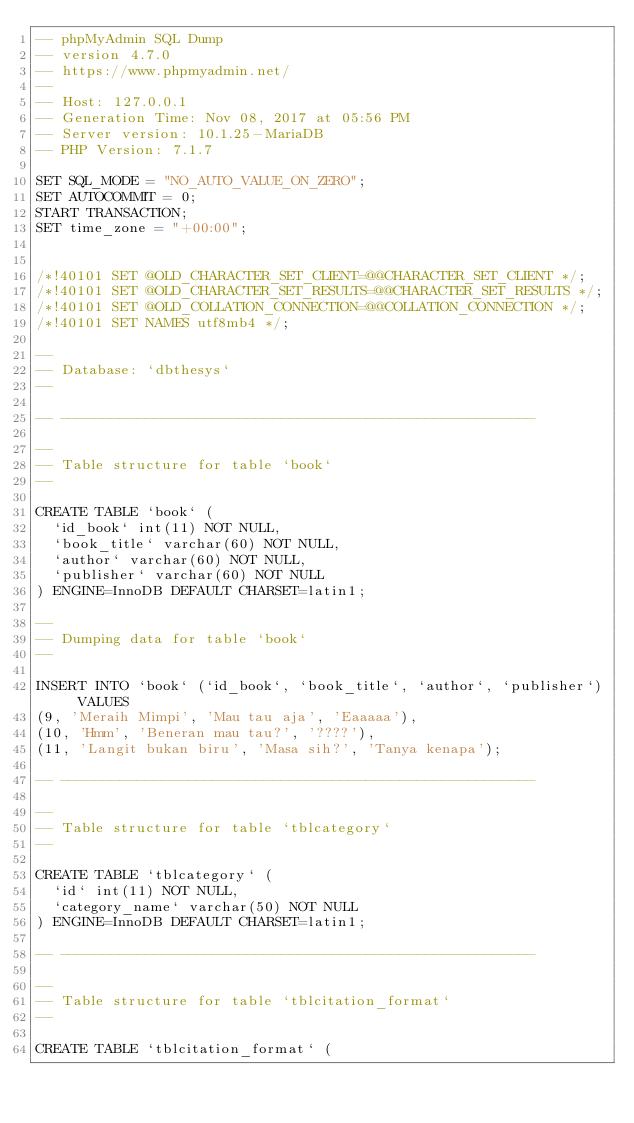<code> <loc_0><loc_0><loc_500><loc_500><_SQL_>-- phpMyAdmin SQL Dump
-- version 4.7.0
-- https://www.phpmyadmin.net/
--
-- Host: 127.0.0.1
-- Generation Time: Nov 08, 2017 at 05:56 PM
-- Server version: 10.1.25-MariaDB
-- PHP Version: 7.1.7

SET SQL_MODE = "NO_AUTO_VALUE_ON_ZERO";
SET AUTOCOMMIT = 0;
START TRANSACTION;
SET time_zone = "+00:00";


/*!40101 SET @OLD_CHARACTER_SET_CLIENT=@@CHARACTER_SET_CLIENT */;
/*!40101 SET @OLD_CHARACTER_SET_RESULTS=@@CHARACTER_SET_RESULTS */;
/*!40101 SET @OLD_COLLATION_CONNECTION=@@COLLATION_CONNECTION */;
/*!40101 SET NAMES utf8mb4 */;

--
-- Database: `dbthesys`
--

-- --------------------------------------------------------

--
-- Table structure for table `book`
--

CREATE TABLE `book` (
  `id_book` int(11) NOT NULL,
  `book_title` varchar(60) NOT NULL,
  `author` varchar(60) NOT NULL,
  `publisher` varchar(60) NOT NULL
) ENGINE=InnoDB DEFAULT CHARSET=latin1;

--
-- Dumping data for table `book`
--

INSERT INTO `book` (`id_book`, `book_title`, `author`, `publisher`) VALUES
(9, 'Meraih Mimpi', 'Mau tau aja', 'Eaaaaa'),
(10, 'Hmm', 'Beneran mau tau?', '????'),
(11, 'Langit bukan biru', 'Masa sih?', 'Tanya kenapa');

-- --------------------------------------------------------

--
-- Table structure for table `tblcategory`
--

CREATE TABLE `tblcategory` (
  `id` int(11) NOT NULL,
  `category_name` varchar(50) NOT NULL
) ENGINE=InnoDB DEFAULT CHARSET=latin1;

-- --------------------------------------------------------

--
-- Table structure for table `tblcitation_format`
--

CREATE TABLE `tblcitation_format` (</code> 